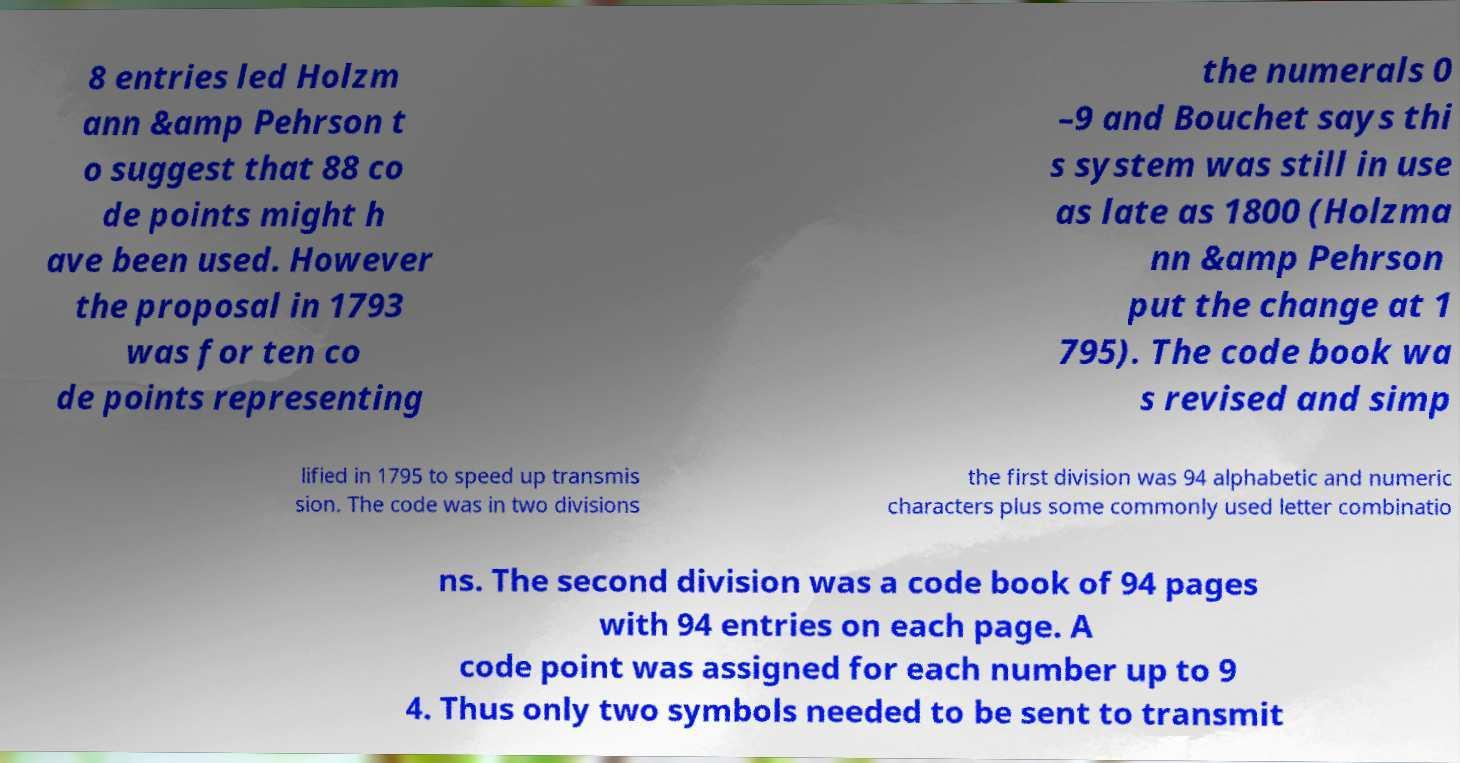I need the written content from this picture converted into text. Can you do that? 8 entries led Holzm ann &amp Pehrson t o suggest that 88 co de points might h ave been used. However the proposal in 1793 was for ten co de points representing the numerals 0 –9 and Bouchet says thi s system was still in use as late as 1800 (Holzma nn &amp Pehrson put the change at 1 795). The code book wa s revised and simp lified in 1795 to speed up transmis sion. The code was in two divisions the first division was 94 alphabetic and numeric characters plus some commonly used letter combinatio ns. The second division was a code book of 94 pages with 94 entries on each page. A code point was assigned for each number up to 9 4. Thus only two symbols needed to be sent to transmit 